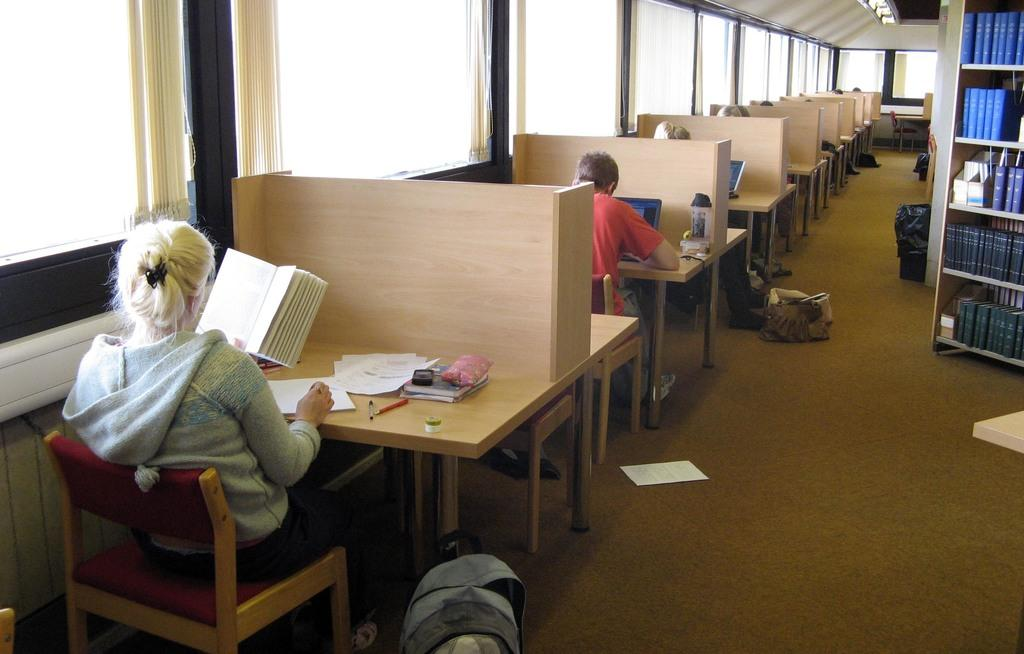Who is the main subject in the image? There is a woman in the image. What is the woman doing in the image? The woman is sitting on a chair and reading. What can be seen in the background of the image? There are bookshelves in the image. What type of ray is visible in the image? There is no ray present in the image. How does the woman make her decision while reading in the image? The image does not show the woman making a decision; it only shows her reading. 